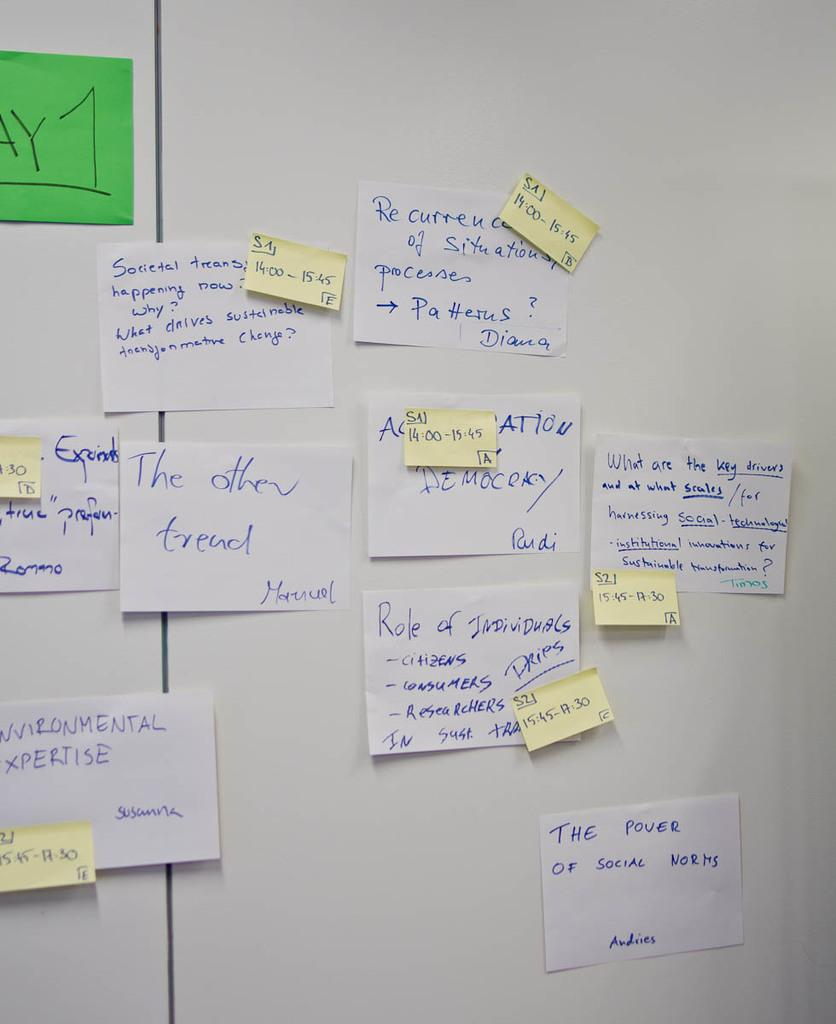<image>
Provide a brief description of the given image. A white wall with lots of notes taped to it, including one that says Environmental Expertise 